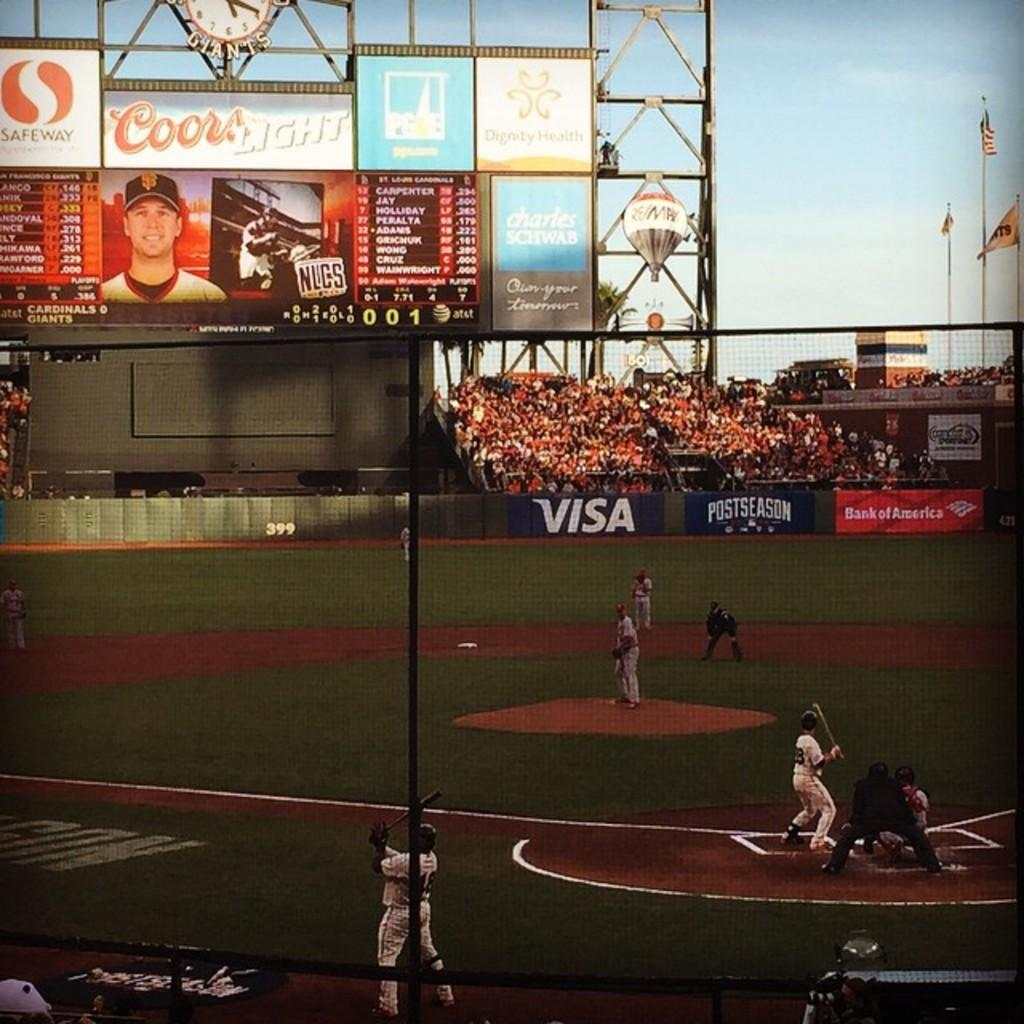<image>
Present a compact description of the photo's key features. A Coor's light ad hangs in a baseball stadium. 